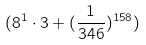<formula> <loc_0><loc_0><loc_500><loc_500>( 8 ^ { 1 } \cdot 3 + ( \frac { 1 } { 3 4 6 } ) ^ { 1 5 8 } )</formula> 